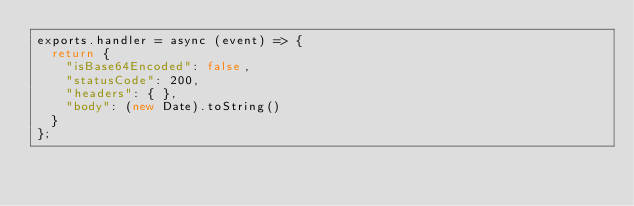Convert code to text. <code><loc_0><loc_0><loc_500><loc_500><_JavaScript_>exports.handler = async (event) => {
  return {
    "isBase64Encoded": false,
    "statusCode": 200,
    "headers": { },
    "body": (new Date).toString()
  }
};

</code> 